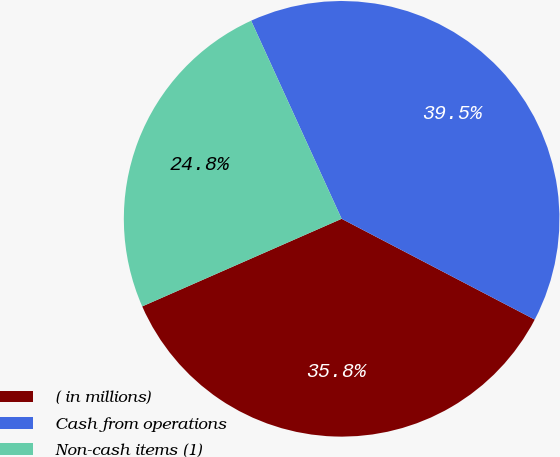<chart> <loc_0><loc_0><loc_500><loc_500><pie_chart><fcel>( in millions)<fcel>Cash from operations<fcel>Non-cash items (1)<nl><fcel>35.76%<fcel>39.48%<fcel>24.77%<nl></chart> 